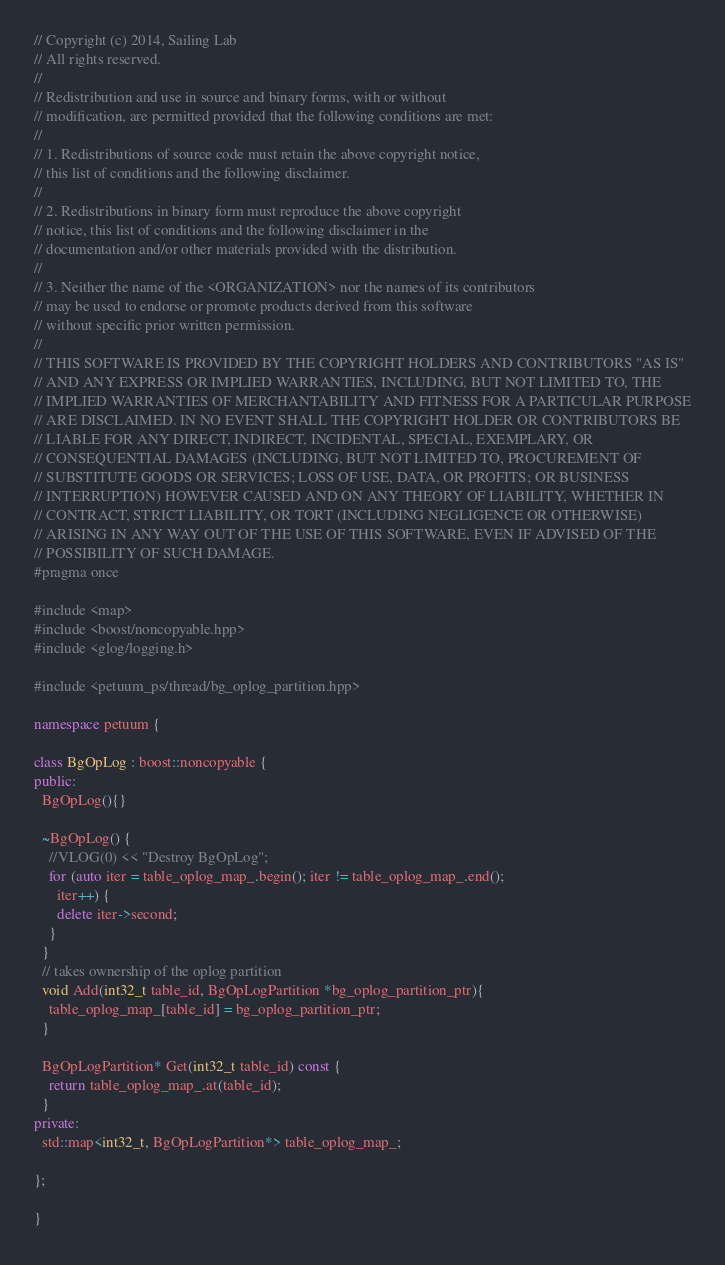Convert code to text. <code><loc_0><loc_0><loc_500><loc_500><_C++_>// Copyright (c) 2014, Sailing Lab
// All rights reserved.
//
// Redistribution and use in source and binary forms, with or without
// modification, are permitted provided that the following conditions are met:
//
// 1. Redistributions of source code must retain the above copyright notice,
// this list of conditions and the following disclaimer.
//
// 2. Redistributions in binary form must reproduce the above copyright
// notice, this list of conditions and the following disclaimer in the
// documentation and/or other materials provided with the distribution.
//
// 3. Neither the name of the <ORGANIZATION> nor the names of its contributors
// may be used to endorse or promote products derived from this software
// without specific prior written permission.
//
// THIS SOFTWARE IS PROVIDED BY THE COPYRIGHT HOLDERS AND CONTRIBUTORS "AS IS"
// AND ANY EXPRESS OR IMPLIED WARRANTIES, INCLUDING, BUT NOT LIMITED TO, THE
// IMPLIED WARRANTIES OF MERCHANTABILITY AND FITNESS FOR A PARTICULAR PURPOSE
// ARE DISCLAIMED. IN NO EVENT SHALL THE COPYRIGHT HOLDER OR CONTRIBUTORS BE
// LIABLE FOR ANY DIRECT, INDIRECT, INCIDENTAL, SPECIAL, EXEMPLARY, OR
// CONSEQUENTIAL DAMAGES (INCLUDING, BUT NOT LIMITED TO, PROCUREMENT OF
// SUBSTITUTE GOODS OR SERVICES; LOSS OF USE, DATA, OR PROFITS; OR BUSINESS
// INTERRUPTION) HOWEVER CAUSED AND ON ANY THEORY OF LIABILITY, WHETHER IN
// CONTRACT, STRICT LIABILITY, OR TORT (INCLUDING NEGLIGENCE OR OTHERWISE)
// ARISING IN ANY WAY OUT OF THE USE OF THIS SOFTWARE, EVEN IF ADVISED OF THE
// POSSIBILITY OF SUCH DAMAGE.
#pragma once

#include <map>
#include <boost/noncopyable.hpp>
#include <glog/logging.h>

#include <petuum_ps/thread/bg_oplog_partition.hpp>

namespace petuum {

class BgOpLog : boost::noncopyable {
public:
  BgOpLog(){}

  ~BgOpLog() {
    //VLOG(0) << "Destroy BgOpLog";
    for (auto iter = table_oplog_map_.begin(); iter != table_oplog_map_.end();
      iter++) {
      delete iter->second;
    }
  }
  // takes ownership of the oplog partition
  void Add(int32_t table_id, BgOpLogPartition *bg_oplog_partition_ptr){
    table_oplog_map_[table_id] = bg_oplog_partition_ptr;
  }

  BgOpLogPartition* Get(int32_t table_id) const {
    return table_oplog_map_.at(table_id);
  }
private:
  std::map<int32_t, BgOpLogPartition*> table_oplog_map_;

};

}
</code> 